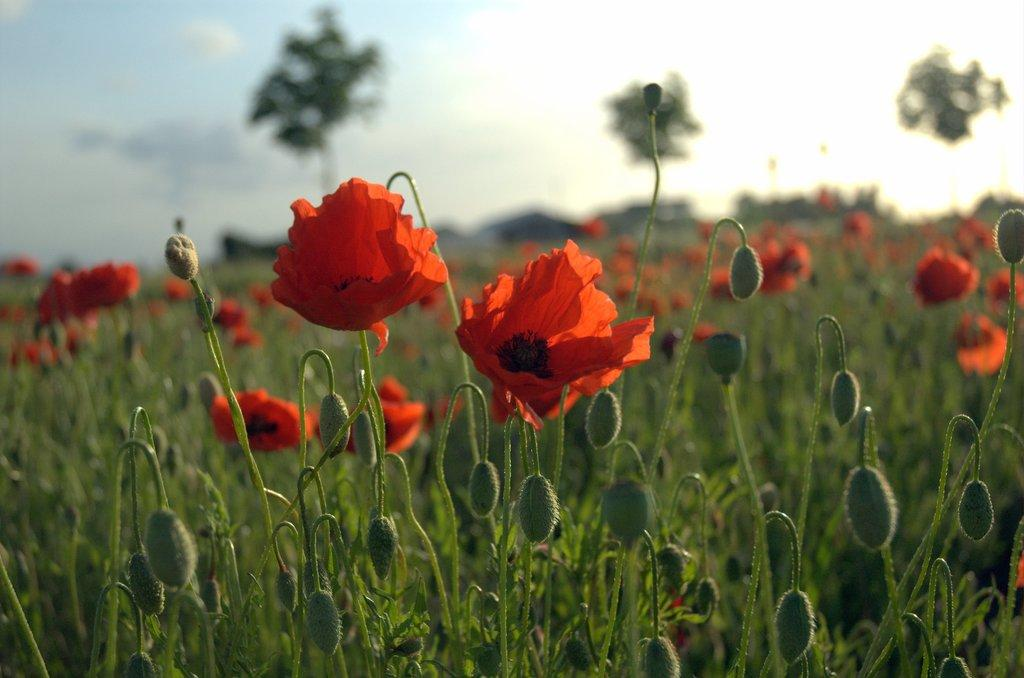Where was the image taken? The image was clicked outside. What can be seen in the image besides the outdoor setting? There are many flowers and plants in the image. What color are the flowers in the image? The flowers in the image are red. What is visible in the sky at the top of the image? There are clouds in the sky at the top of the image. What verse is being recited by the kittens in the image? There are no kittens present in the image, and therefore no verse is being recited. 